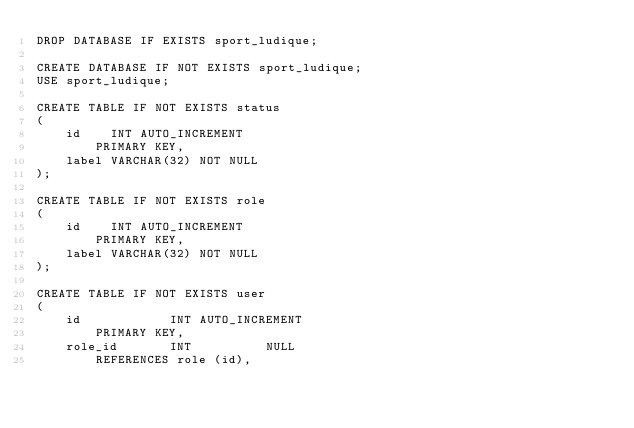Convert code to text. <code><loc_0><loc_0><loc_500><loc_500><_SQL_>DROP DATABASE IF EXISTS sport_ludique;

CREATE DATABASE IF NOT EXISTS sport_ludique;
USE sport_ludique;

CREATE TABLE IF NOT EXISTS status
(
    id    INT AUTO_INCREMENT
        PRIMARY KEY,
    label VARCHAR(32) NOT NULL
);

CREATE TABLE IF NOT EXISTS role
(
    id    INT AUTO_INCREMENT
        PRIMARY KEY,
    label VARCHAR(32) NOT NULL
);

CREATE TABLE IF NOT EXISTS user
(
    id            INT AUTO_INCREMENT
        PRIMARY KEY,
    role_id       INT          NULL
        REFERENCES role (id),</code> 